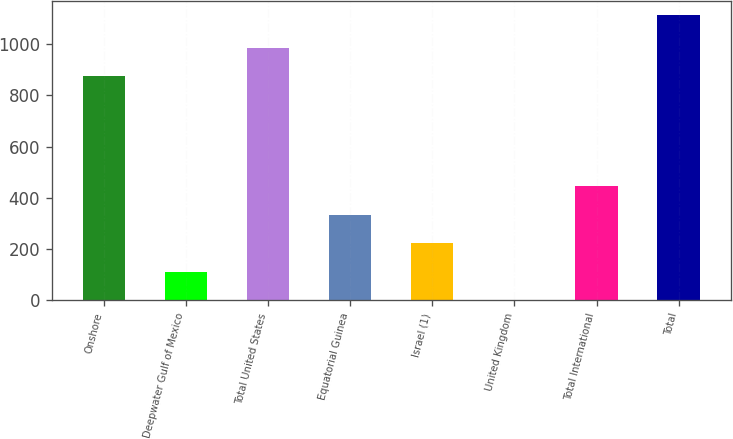Convert chart to OTSL. <chart><loc_0><loc_0><loc_500><loc_500><bar_chart><fcel>Onshore<fcel>Deepwater Gulf of Mexico<fcel>Total United States<fcel>Equatorial Guinea<fcel>Israel (1)<fcel>United Kingdom<fcel>Total International<fcel>Total<nl><fcel>874<fcel>112.1<fcel>985.1<fcel>334.3<fcel>223.2<fcel>1<fcel>445.4<fcel>1112<nl></chart> 